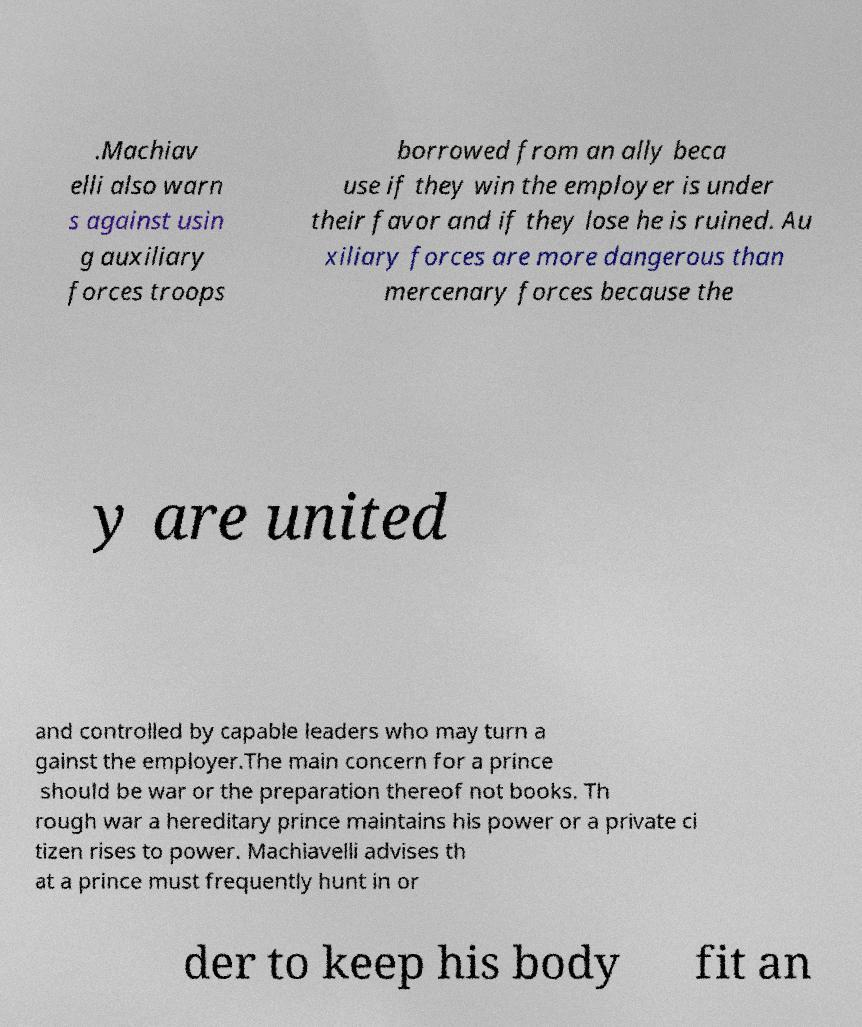Can you read and provide the text displayed in the image?This photo seems to have some interesting text. Can you extract and type it out for me? .Machiav elli also warn s against usin g auxiliary forces troops borrowed from an ally beca use if they win the employer is under their favor and if they lose he is ruined. Au xiliary forces are more dangerous than mercenary forces because the y are united and controlled by capable leaders who may turn a gainst the employer.The main concern for a prince should be war or the preparation thereof not books. Th rough war a hereditary prince maintains his power or a private ci tizen rises to power. Machiavelli advises th at a prince must frequently hunt in or der to keep his body fit an 